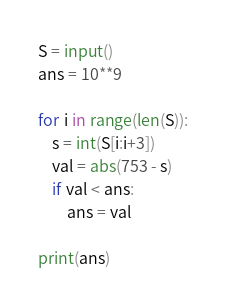Convert code to text. <code><loc_0><loc_0><loc_500><loc_500><_Python_>S = input()
ans = 10**9

for i in range(len(S)):
    s = int(S[i:i+3])
    val = abs(753 - s)
    if val < ans:
        ans = val

print(ans)</code> 